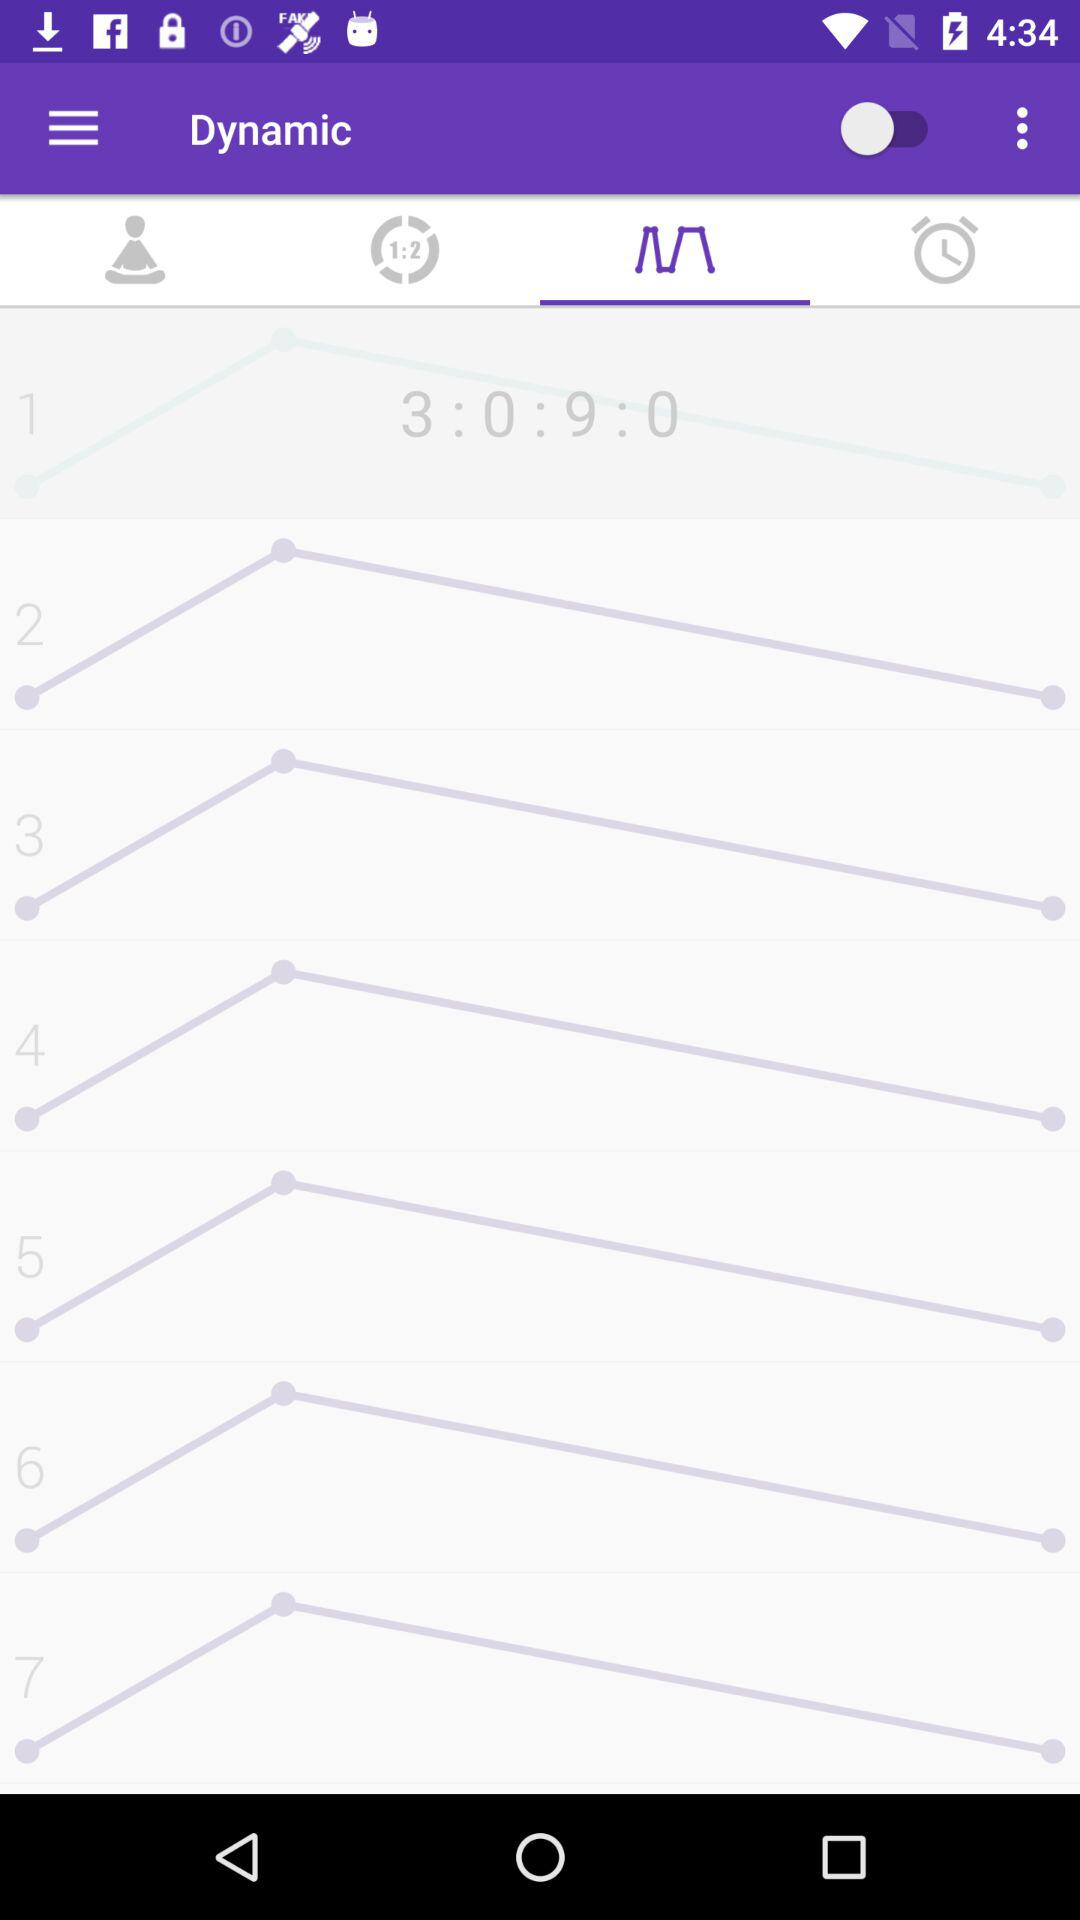What is the profile name?
When the provided information is insufficient, respond with <no answer>. <no answer> 